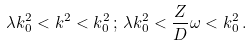<formula> <loc_0><loc_0><loc_500><loc_500>\lambda k _ { 0 } ^ { 2 } < k ^ { 2 } < k _ { 0 } ^ { 2 } \, ; \, \lambda k _ { 0 } ^ { 2 } < \frac { Z } { D } \omega < k _ { 0 } ^ { 2 } \, .</formula> 